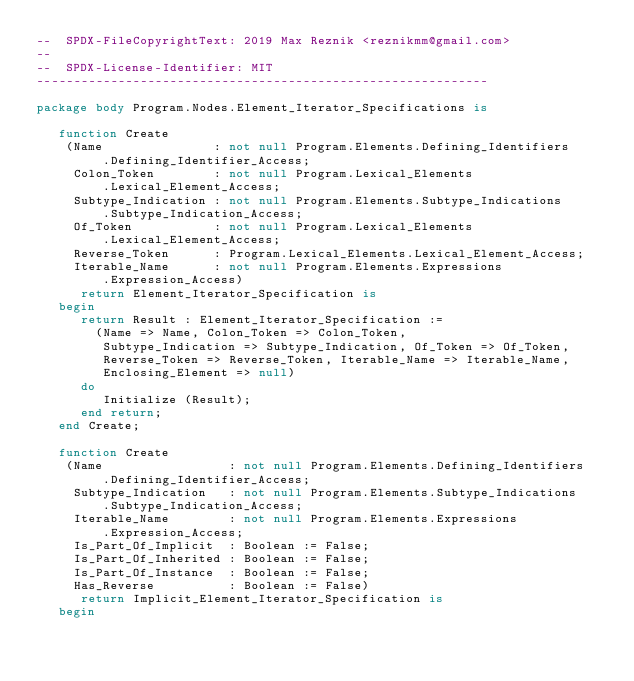Convert code to text. <code><loc_0><loc_0><loc_500><loc_500><_Ada_>--  SPDX-FileCopyrightText: 2019 Max Reznik <reznikmm@gmail.com>
--
--  SPDX-License-Identifier: MIT
-------------------------------------------------------------

package body Program.Nodes.Element_Iterator_Specifications is

   function Create
    (Name               : not null Program.Elements.Defining_Identifiers
         .Defining_Identifier_Access;
     Colon_Token        : not null Program.Lexical_Elements
         .Lexical_Element_Access;
     Subtype_Indication : not null Program.Elements.Subtype_Indications
         .Subtype_Indication_Access;
     Of_Token           : not null Program.Lexical_Elements
         .Lexical_Element_Access;
     Reverse_Token      : Program.Lexical_Elements.Lexical_Element_Access;
     Iterable_Name      : not null Program.Elements.Expressions
         .Expression_Access)
      return Element_Iterator_Specification is
   begin
      return Result : Element_Iterator_Specification :=
        (Name => Name, Colon_Token => Colon_Token,
         Subtype_Indication => Subtype_Indication, Of_Token => Of_Token,
         Reverse_Token => Reverse_Token, Iterable_Name => Iterable_Name,
         Enclosing_Element => null)
      do
         Initialize (Result);
      end return;
   end Create;

   function Create
    (Name                 : not null Program.Elements.Defining_Identifiers
         .Defining_Identifier_Access;
     Subtype_Indication   : not null Program.Elements.Subtype_Indications
         .Subtype_Indication_Access;
     Iterable_Name        : not null Program.Elements.Expressions
         .Expression_Access;
     Is_Part_Of_Implicit  : Boolean := False;
     Is_Part_Of_Inherited : Boolean := False;
     Is_Part_Of_Instance  : Boolean := False;
     Has_Reverse          : Boolean := False)
      return Implicit_Element_Iterator_Specification is
   begin</code> 